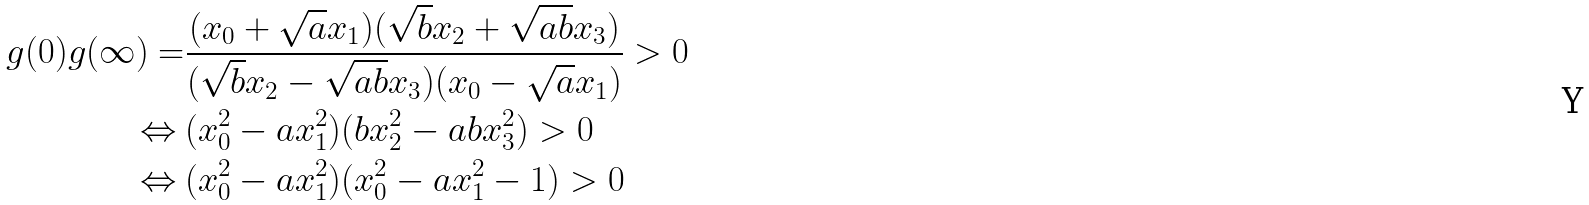Convert formula to latex. <formula><loc_0><loc_0><loc_500><loc_500>g ( 0 ) g ( \infty ) = & \frac { ( x _ { 0 } + \sqrt { a } x _ { 1 } ) ( \sqrt { b } x _ { 2 } + \sqrt { a b } x _ { 3 } ) } { ( \sqrt { b } x _ { 2 } - \sqrt { a b } x _ { 3 } ) ( x _ { 0 } - \sqrt { a } x _ { 1 } ) } > 0 \\ \Leftrightarrow \ & ( x _ { 0 } ^ { 2 } - a x _ { 1 } ^ { 2 } ) ( b x _ { 2 } ^ { 2 } - a b x _ { 3 } ^ { 2 } ) > 0 \\ \Leftrightarrow \ & ( x _ { 0 } ^ { 2 } - a x _ { 1 } ^ { 2 } ) ( x _ { 0 } ^ { 2 } - a x _ { 1 } ^ { 2 } - 1 ) > 0</formula> 